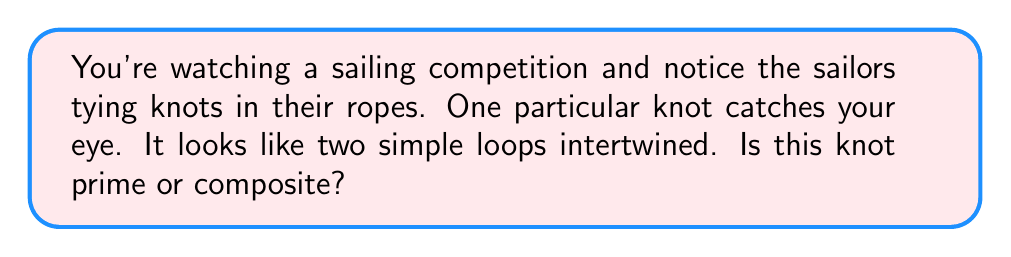Give your solution to this math problem. Let's approach this step-by-step:

1) First, we need to understand what prime and composite knots are:
   - A prime knot is a knot that cannot be decomposed into simpler knots.
   - A composite knot is formed by connecting two or more prime knots.

2) The knot described in the question is two simple loops intertwined. This is a key characteristic of a specific knot called the "Figure-8 knot".

3) The Figure-8 knot, despite its appearance of two loops, is actually a prime knot. Here's why:

   a) It cannot be separated into two simpler knots without cutting the rope.
   
   b) If we try to "untangle" one loop, we end up complicating the other loop.
   
   c) Mathematically, it has been proven that the Figure-8 knot is prime using techniques such as studying its complement in $S^3$ (the 3-sphere).

4) A simple way to visualize this is to imagine trying to pull the knot apart. Unlike a truly composite knot, you can't separate the Figure-8 into two distinct knots.

5) Therefore, despite its appearance of two intertwined loops, this knot is actually prime.
Answer: Prime 